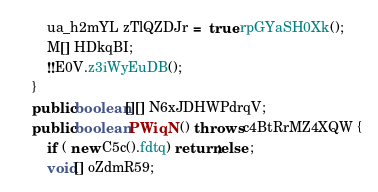<code> <loc_0><loc_0><loc_500><loc_500><_Java_>        ua_h2mYL zTlQZDJr =  true.rpGYaSH0Xk();
        M[] HDkqBI;
        !!E0V.z3iWyEuDB();
    }
    public boolean[][] N6xJDHWPdrqV;
    public boolean PWiqN () throws c4BtRrMZ4XQW {
        if ( new C5c().fdtq) return;else ;
        void[] oZdmR59;</code> 